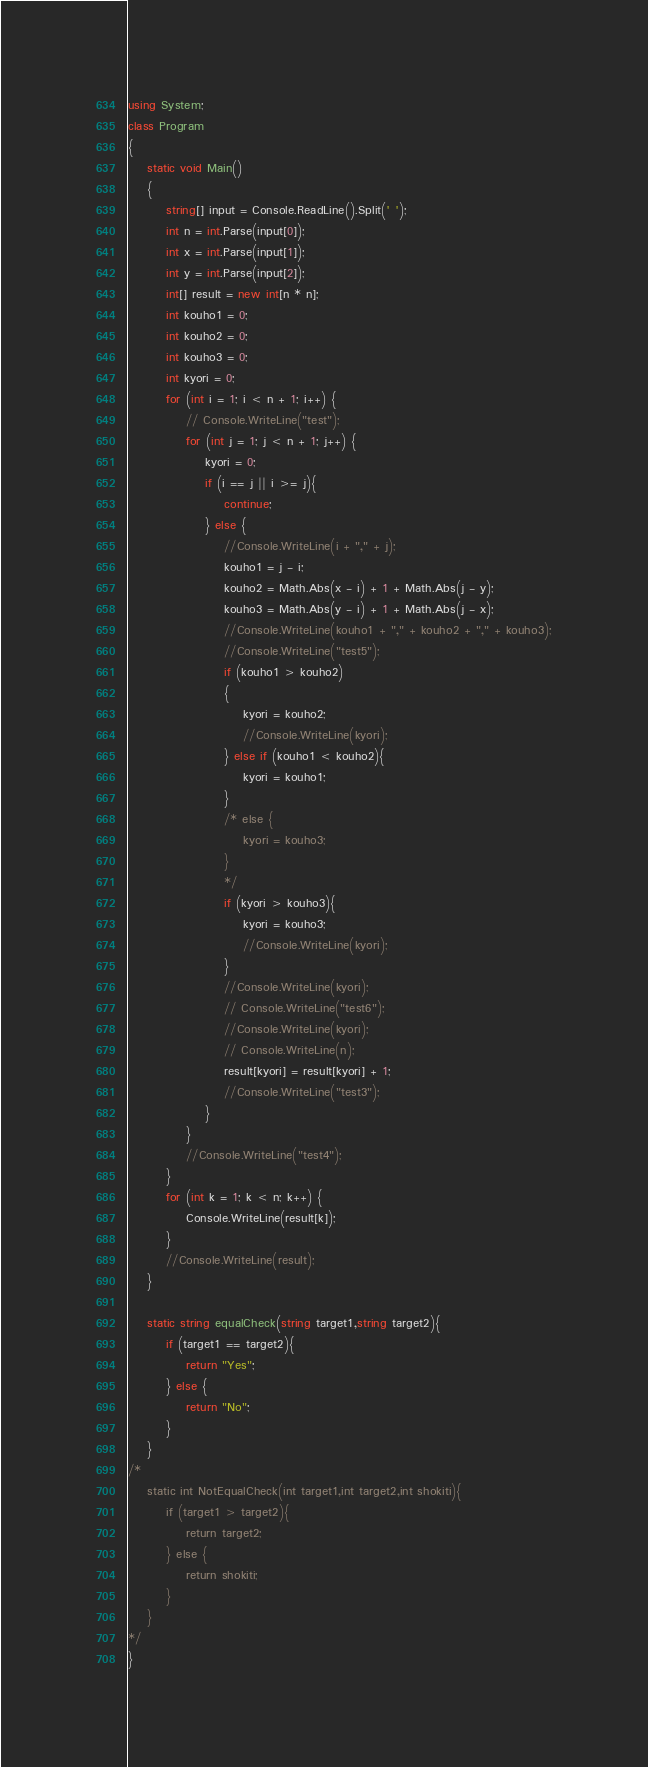<code> <loc_0><loc_0><loc_500><loc_500><_C#_>using System;
class Program
{
	static void Main()
	{
        string[] input = Console.ReadLine().Split(' ');
        int n = int.Parse(input[0]);
        int x = int.Parse(input[1]);
        int y = int.Parse(input[2]);
        int[] result = new int[n * n];
        int kouho1 = 0;
        int kouho2 = 0;
        int kouho3 = 0;
        int kyori = 0;
        for (int i = 1; i < n + 1; i++) {
            // Console.WriteLine("test");
            for (int j = 1; j < n + 1; j++) {
                kyori = 0;
                if (i == j || i >= j){
                    continue;
                } else {
                    //Console.WriteLine(i + "," + j);
                    kouho1 = j - i;
                    kouho2 = Math.Abs(x - i) + 1 + Math.Abs(j - y);
                    kouho3 = Math.Abs(y - i) + 1 + Math.Abs(j - x);
                    //Console.WriteLine(kouho1 + "," + kouho2 + "," + kouho3);
                    //Console.WriteLine("test5");
                    if (kouho1 > kouho2)
                    {
                        kyori = kouho2;
                        //Console.WriteLine(kyori);
                    } else if (kouho1 < kouho2){
                        kyori = kouho1;
                    }
                    /* else {
                        kyori = kouho3;
                    }
                    */
                    if (kyori > kouho3){
                        kyori = kouho3;
                        //Console.WriteLine(kyori);
                    }
                    //Console.WriteLine(kyori);
                    // Console.WriteLine("test6");
                    //Console.WriteLine(kyori);
                    // Console.WriteLine(n);
                    result[kyori] = result[kyori] + 1;
                    //Console.WriteLine("test3");
                }
            }
            //Console.WriteLine("test4");
        }
        for (int k = 1; k < n; k++) {
            Console.WriteLine(result[k]);
        }
        //Console.WriteLine(result);
	}

    static string equalCheck(string target1,string target2){
        if (target1 == target2){
            return "Yes";
        } else {
            return "No";
        }
    }
/*
    static int NotEqualCheck(int target1,int target2,int shokiti){
        if (target1 > target2){
            return target2;
        } else {
            return shokiti;
        }
    }
*/
}</code> 